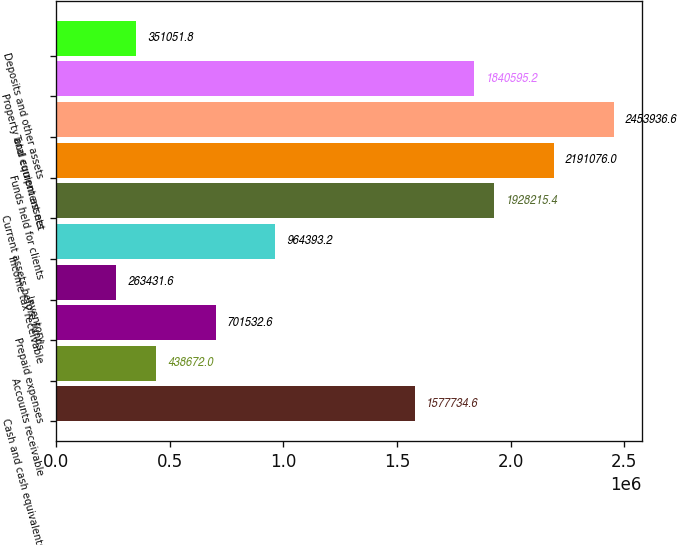Convert chart to OTSL. <chart><loc_0><loc_0><loc_500><loc_500><bar_chart><fcel>Cash and cash equivalents<fcel>Accounts receivable<fcel>Prepaid expenses<fcel>Inventory<fcel>Income tax receivable<fcel>Current assets before funds<fcel>Funds held for clients<fcel>Total current assets<fcel>Property and equipment net<fcel>Deposits and other assets<nl><fcel>1.57773e+06<fcel>438672<fcel>701533<fcel>263432<fcel>964393<fcel>1.92822e+06<fcel>2.19108e+06<fcel>2.45394e+06<fcel>1.8406e+06<fcel>351052<nl></chart> 